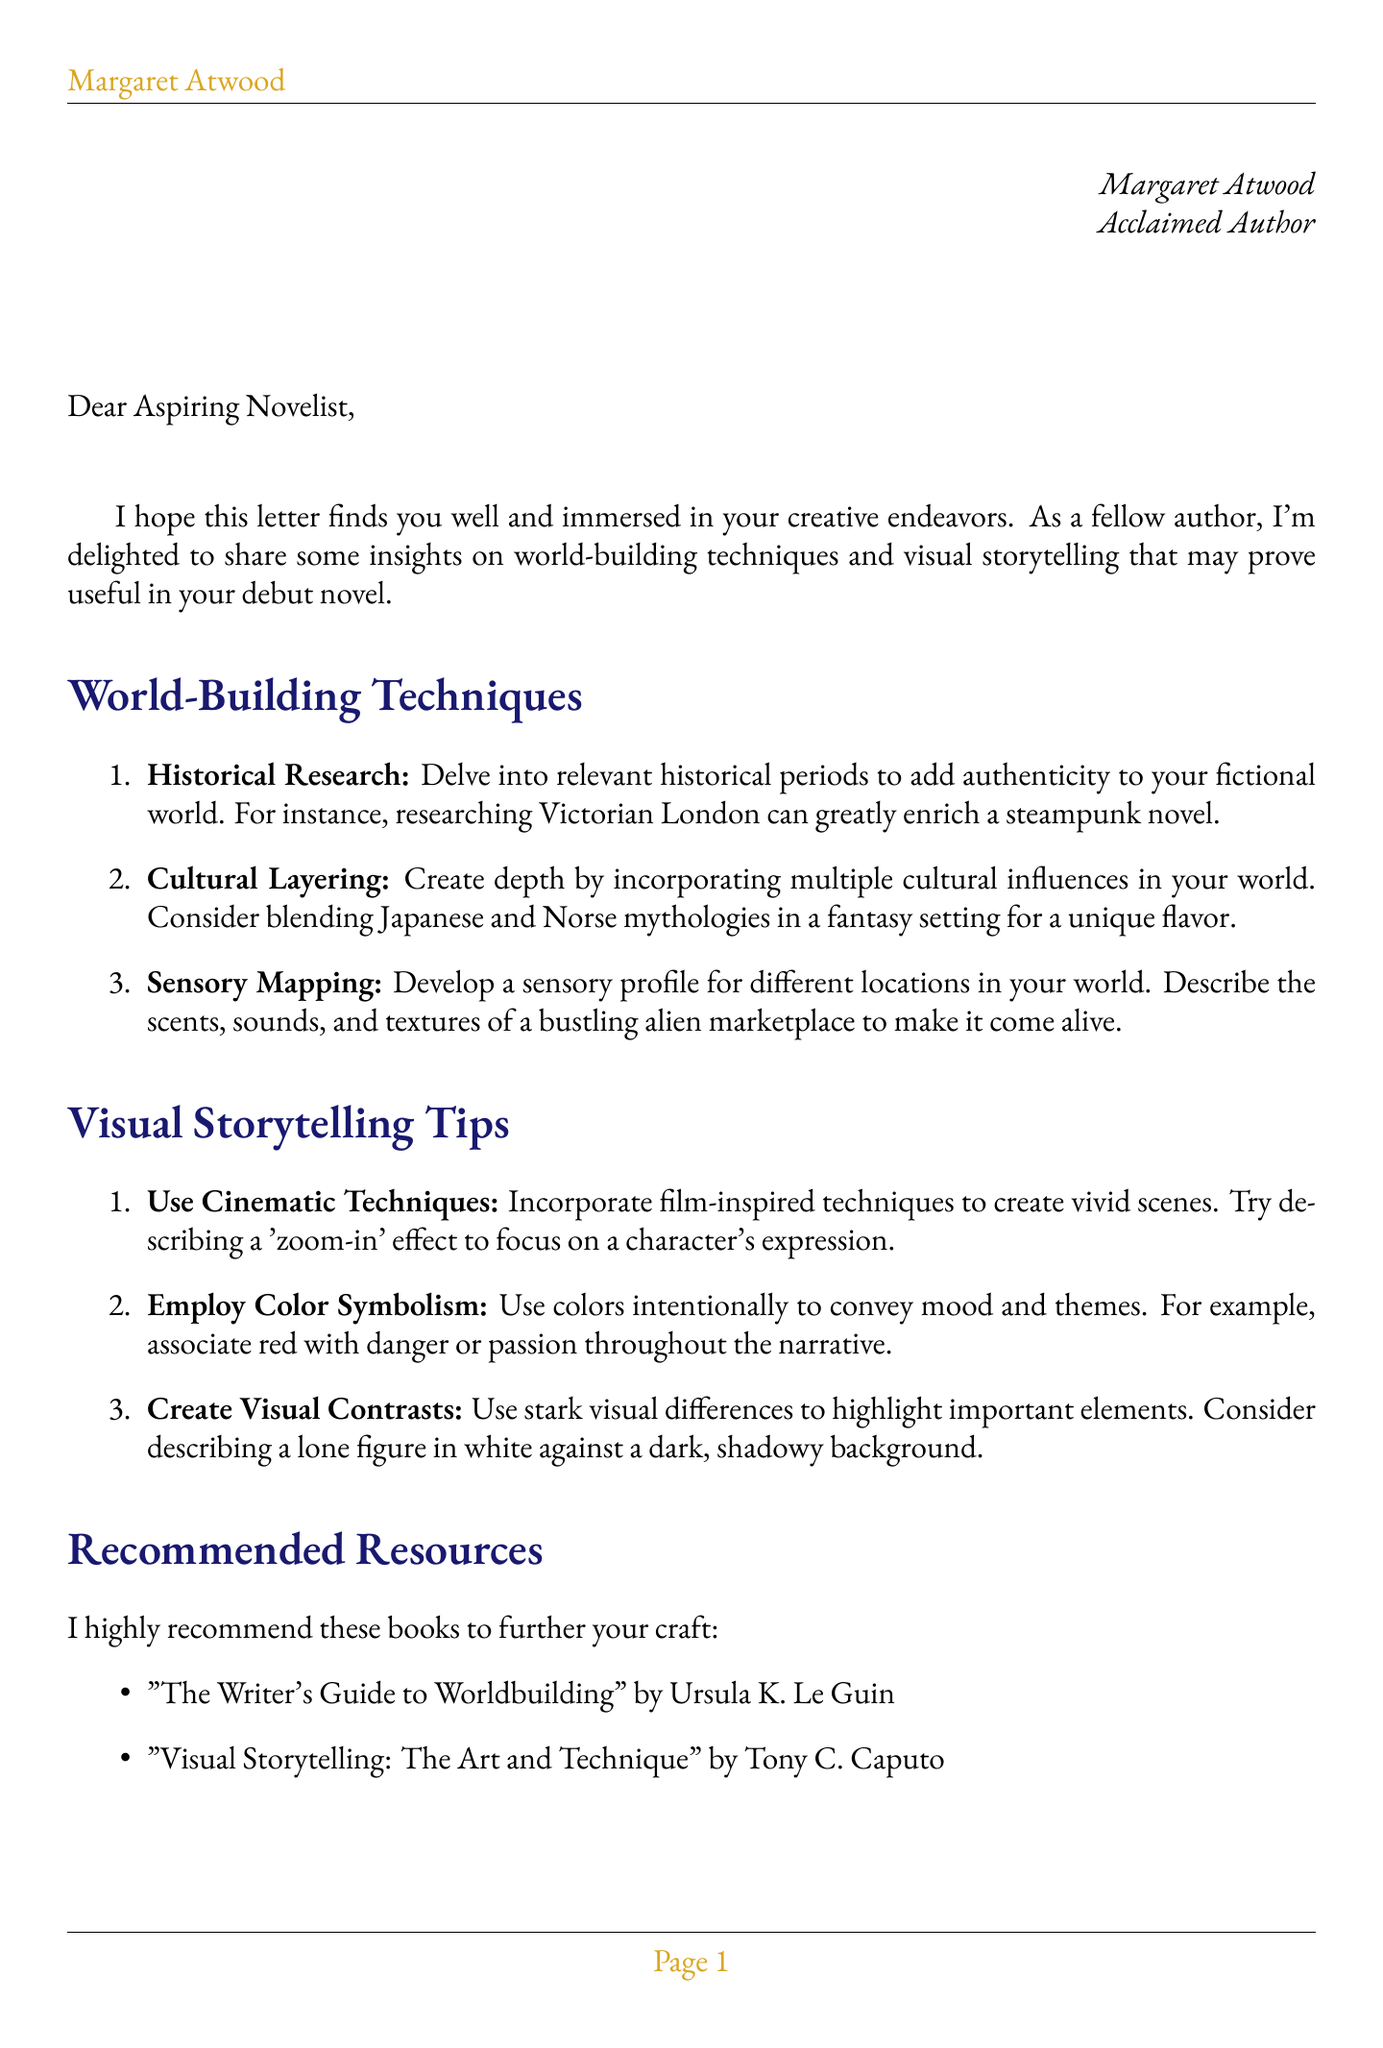What is the name of the sender? The sender of the letter is identified as Margaret Atwood.
Answer: Margaret Atwood What occupation does the sender hold? The document states that the sender is an acclaimed author.
Answer: Acclaimed Author What is one world-building technique mentioned? The document lists several techniques; one is Historical Research.
Answer: Historical Research Which book is suggested as a resource for world-building? The letter recommends a specific book for world-building.
Answer: The Writer's Guide to Worldbuilding What genre-specific advice is provided in the document? The letter includes advice tailored for a specific genre, which is Science Fiction.
Answer: Science Fiction How many visual storytelling tips are provided? The document lists three tips under visual storytelling.
Answer: Three What anecdote does the sender include about their own writing experience? The letter mentions a personal story related to the writing of 'The Handmaid's Tale'.
Answer: Researching historical instances of societal oppression What is emphasized about the fictional world you create? The quote highlights the importance of depth and authenticity in world-building.
Answer: A canvas for your characters and plot What should be balanced according to the genre-specific advice? The document advises balancing scientific accuracy with creative speculation.
Answer: Scientific accuracy with creative speculation 